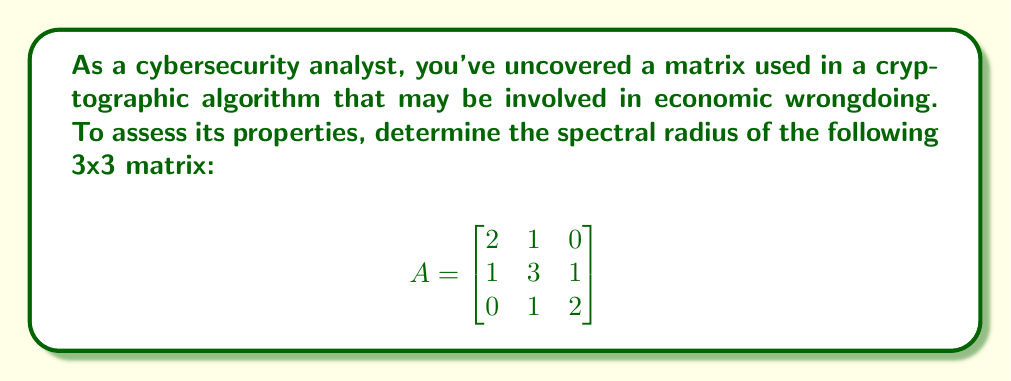What is the answer to this math problem? To find the spectral radius of matrix A, we need to follow these steps:

1. Calculate the eigenvalues of the matrix.
2. Find the absolute values of these eigenvalues.
3. The spectral radius is the maximum of these absolute values.

Step 1: Calculate the eigenvalues

To find the eigenvalues, we need to solve the characteristic equation:
$$\det(A - \lambda I) = 0$$

Expanding this:
$$\begin{vmatrix}
2-\lambda & 1 & 0 \\
1 & 3-\lambda & 1 \\
0 & 1 & 2-\lambda
\end{vmatrix} = 0$$

$$(2-\lambda)[(3-\lambda)(2-\lambda) - 1] - 1(1)(2-\lambda) = 0$$

$$(2-\lambda)[(6-5\lambda+\lambda^2) - 1] - 1(2-\lambda) = 0$$

$$(2-\lambda)(5-5\lambda+\lambda^2) - (2-\lambda) = 0$$

$$10-10\lambda+2\lambda^2-5\lambda+5\lambda^2-\lambda^3-2+\lambda = 0$$

$$-\lambda^3+7\lambda^2-14\lambda+8 = 0$$

This cubic equation can be factored as:
$$(\lambda-1)(\lambda-3)(\lambda-4) = 0$$

Therefore, the eigenvalues are $\lambda_1 = 1$, $\lambda_2 = 3$, and $\lambda_3 = 4$.

Step 2: Find the absolute values

The absolute values are already 1, 3, and 4.

Step 3: Find the maximum

The maximum of these values is 4.
Answer: The spectral radius of the matrix A is 4. 